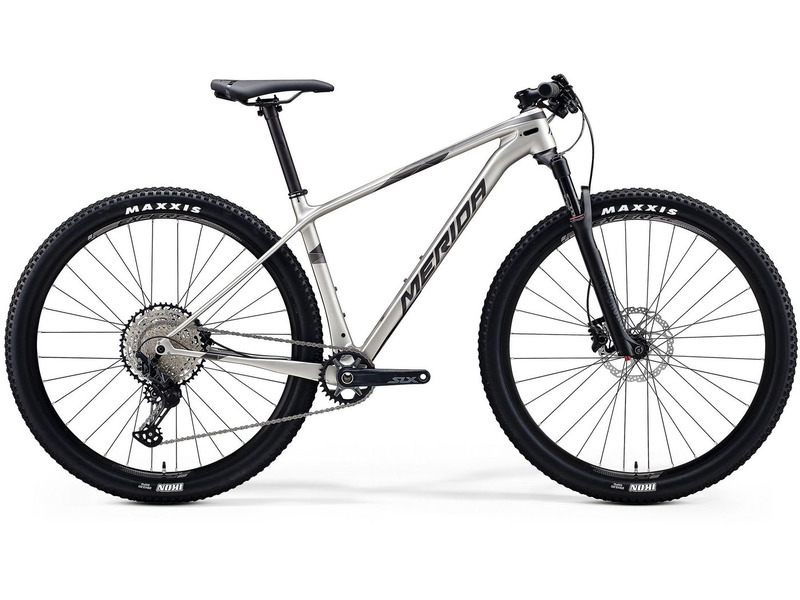Imagine a story where this mountain bike is involved in an adventure. Can you describe the journey? In the heart of a dense forest, amidst towering ancient trees, a lone mountain bike stood poised for adventure. This wasn't just any bike; it was designed for the rugged trails and uncharted paths that awaited beyond. Our protagonist, Alex, a seasoned explorer, mounted the bike, feeling the familiar adrenaline rush as they set off into the unknown.

The trail began with a steep ascent, the knobby MAXXIS tires gripping the loose dirt effortlessly. The front suspension absorbed the bumps and roots, making the climb feel almost effortless. As Alex reached the crest of the hill, the forest opened up to reveal a breathtaking panorama of rolling hills and distant mountains, bathed in the golden light of the morning sun.

Descending into a valley, the trail became more challenging, with sharp turns and rocky sections. The single chainring drivetrain proved invaluable, allowing Alex to navigate the technical terrain with ease. Suddenly, the path veered off into a dense thicket, leading to a secluded waterfall. Here, Alex took a moment to rest, the sound of cascading water providing a serene backdrop to the adventure.

Continuing on, Alex encountered a series of switchbacks that tested both bike and rider. The lightweight frame and agile handling of the bike made it possible to negotiate these bends with precision. Each turn revealed new aspects of the landscape, from trickling streams to clusters of wildflowers in full bloom.

As dusk began to fall, Alex found a perfect campsite by a crystal-clear lake. The adventure wasn't just about the thrill of the ride; it was also about these moments of quiet reflection in nature's embrace. With a sense of accomplishment and peace, Alex settled in for the night, the mountain bike standing sentinel by the tent, ready for the next day's discoveries.

This journey showcased not only the bike's capabilities but also the profound connection between the rider and the wild terrains they traversed. 